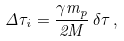Convert formula to latex. <formula><loc_0><loc_0><loc_500><loc_500>\Delta \tau _ { i } = \frac { \gamma m _ { p } } { 2 M } \, \delta \tau \, ,</formula> 